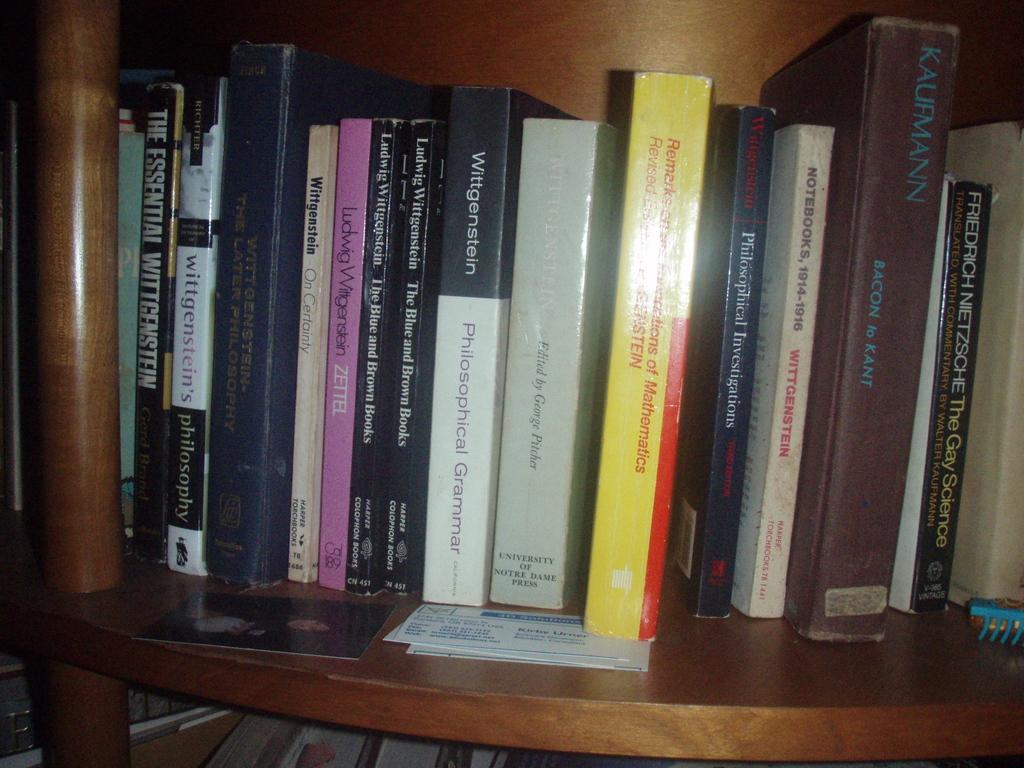What book is black and white?
Ensure brevity in your answer.  Philosophical grammar. What is the name of the black book by nietzsche?
Make the answer very short. The gay science. 